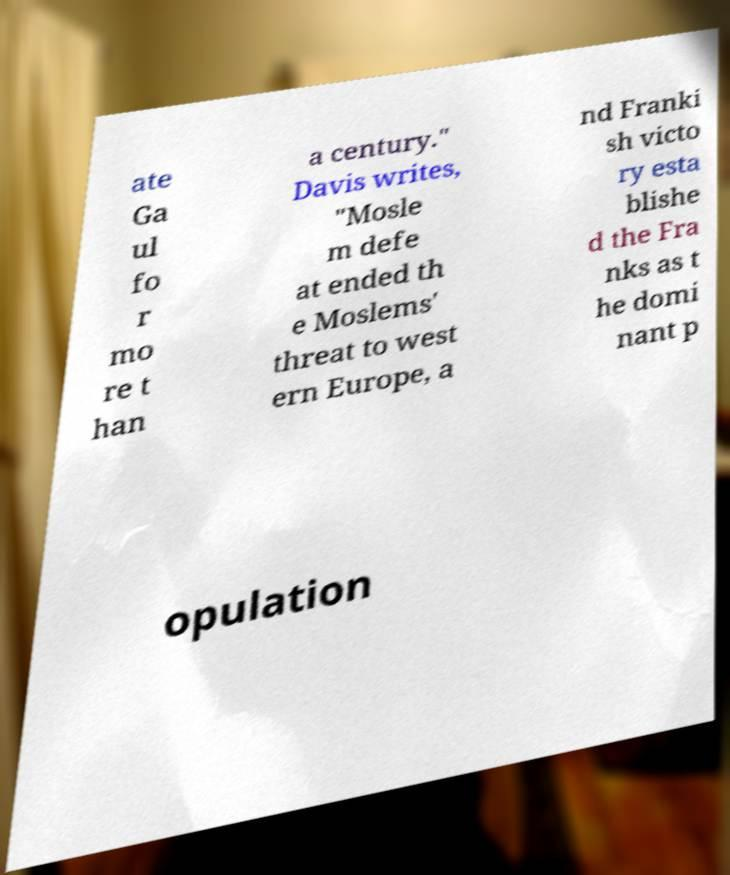For documentation purposes, I need the text within this image transcribed. Could you provide that? ate Ga ul fo r mo re t han a century." Davis writes, "Mosle m defe at ended th e Moslems' threat to west ern Europe, a nd Franki sh victo ry esta blishe d the Fra nks as t he domi nant p opulation 